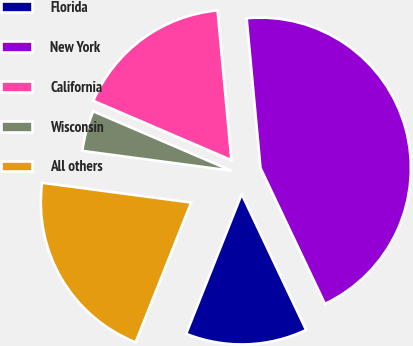<chart> <loc_0><loc_0><loc_500><loc_500><pie_chart><fcel>Florida<fcel>New York<fcel>California<fcel>Wisconsin<fcel>All others<nl><fcel>13.07%<fcel>44.43%<fcel>17.07%<fcel>4.36%<fcel>21.08%<nl></chart> 